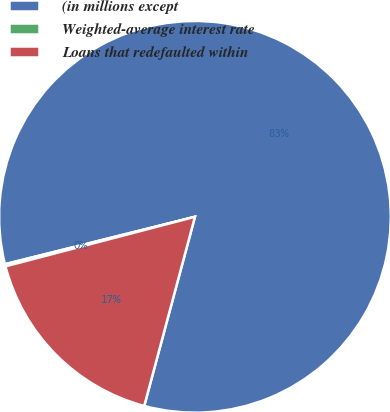<chart> <loc_0><loc_0><loc_500><loc_500><pie_chart><fcel>(in millions except<fcel>Weighted-average interest rate<fcel>Loans that redefaulted within<nl><fcel>83.06%<fcel>0.18%<fcel>16.76%<nl></chart> 